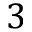Convert formula to latex. <formula><loc_0><loc_0><loc_500><loc_500>3</formula> 